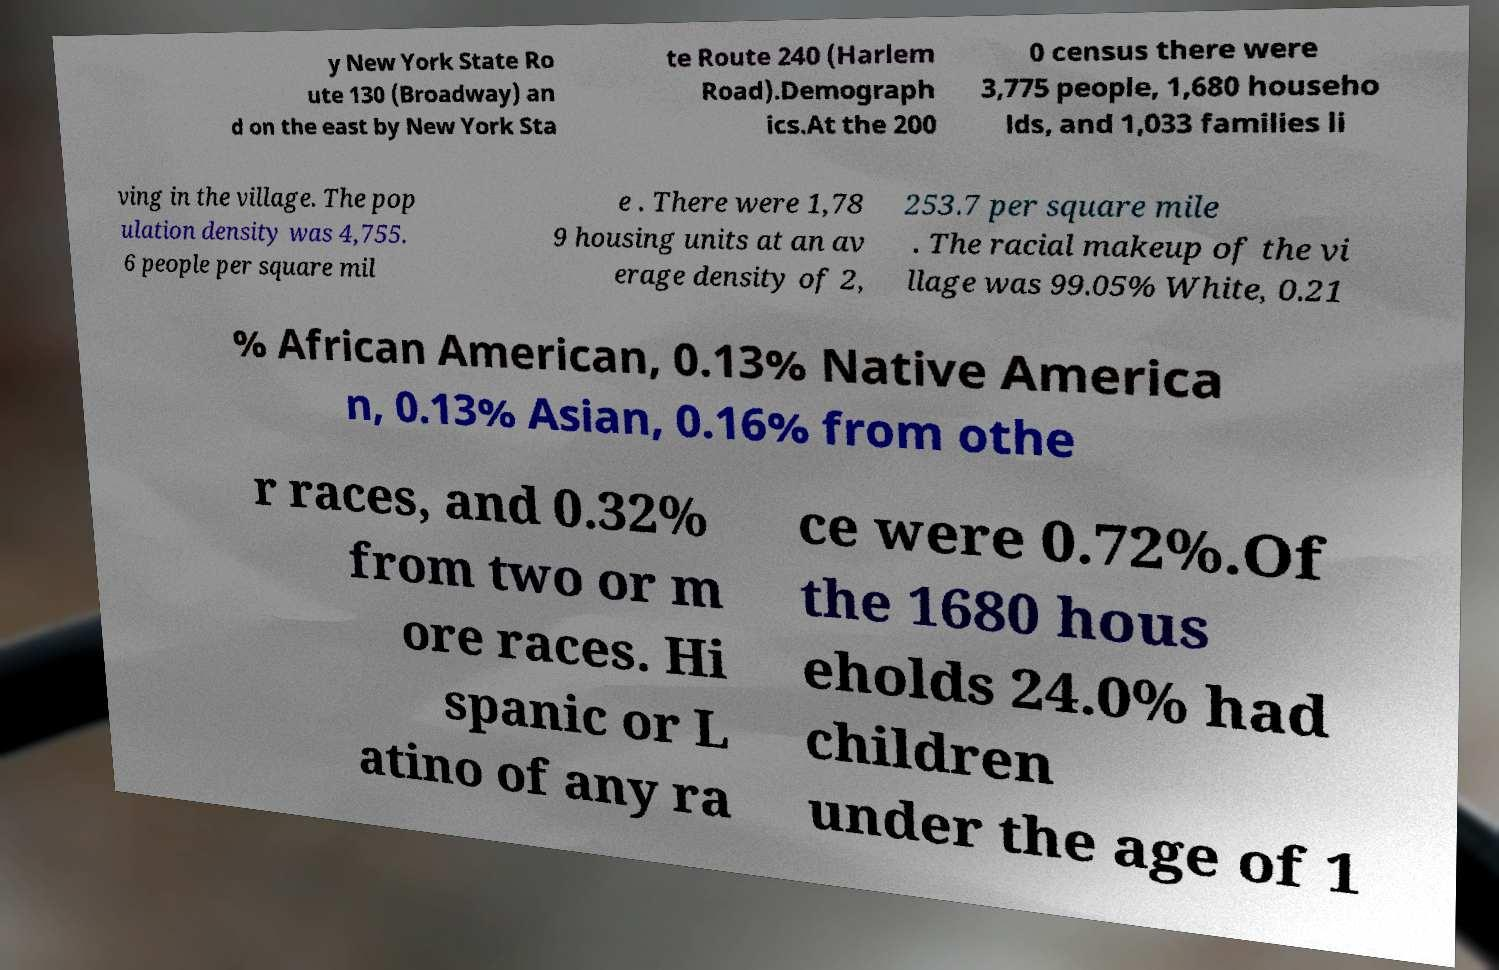Can you read and provide the text displayed in the image?This photo seems to have some interesting text. Can you extract and type it out for me? y New York State Ro ute 130 (Broadway) an d on the east by New York Sta te Route 240 (Harlem Road).Demograph ics.At the 200 0 census there were 3,775 people, 1,680 househo lds, and 1,033 families li ving in the village. The pop ulation density was 4,755. 6 people per square mil e . There were 1,78 9 housing units at an av erage density of 2, 253.7 per square mile . The racial makeup of the vi llage was 99.05% White, 0.21 % African American, 0.13% Native America n, 0.13% Asian, 0.16% from othe r races, and 0.32% from two or m ore races. Hi spanic or L atino of any ra ce were 0.72%.Of the 1680 hous eholds 24.0% had children under the age of 1 